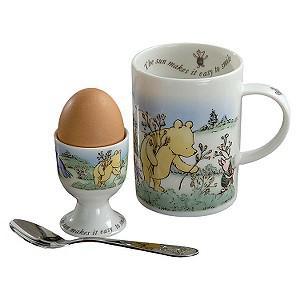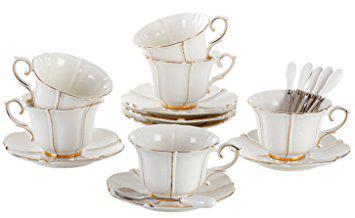The first image is the image on the left, the second image is the image on the right. Examine the images to the left and right. Is the description "An image shows beige dishware that look like melamine plastic." accurate? Answer yes or no. No. 